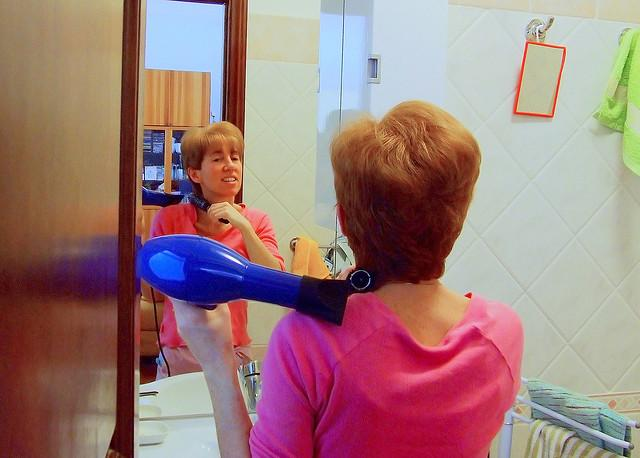What is she doing? Please explain your reasoning. fixing hair. She is using a dryer and brush to style. 